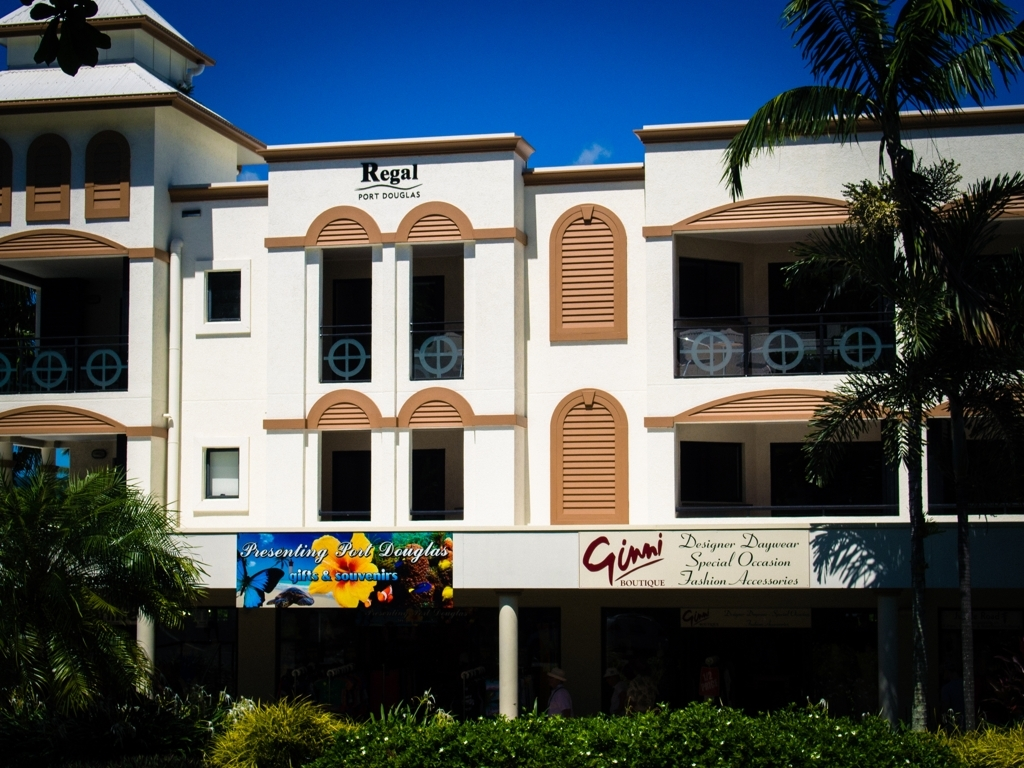What time of day does the image suggest it is? The image seems to have been taken on a bright, sunny day, judging by the strong shadows cast on the building façade and the vibrant blue sky. These factors suggest that the photo was likely taken in the late morning or early afternoon when the sun is high in the sky. What does the presence of palm trees indicate about the location? The presence of palm trees typically suggests a tropical or subtropical climate, which often points to a location near the coast or in regions that enjoy warm weather year-round. Given that, this scene likely takes place in a coastal tourist area, which is supported by the type of businesses present. 